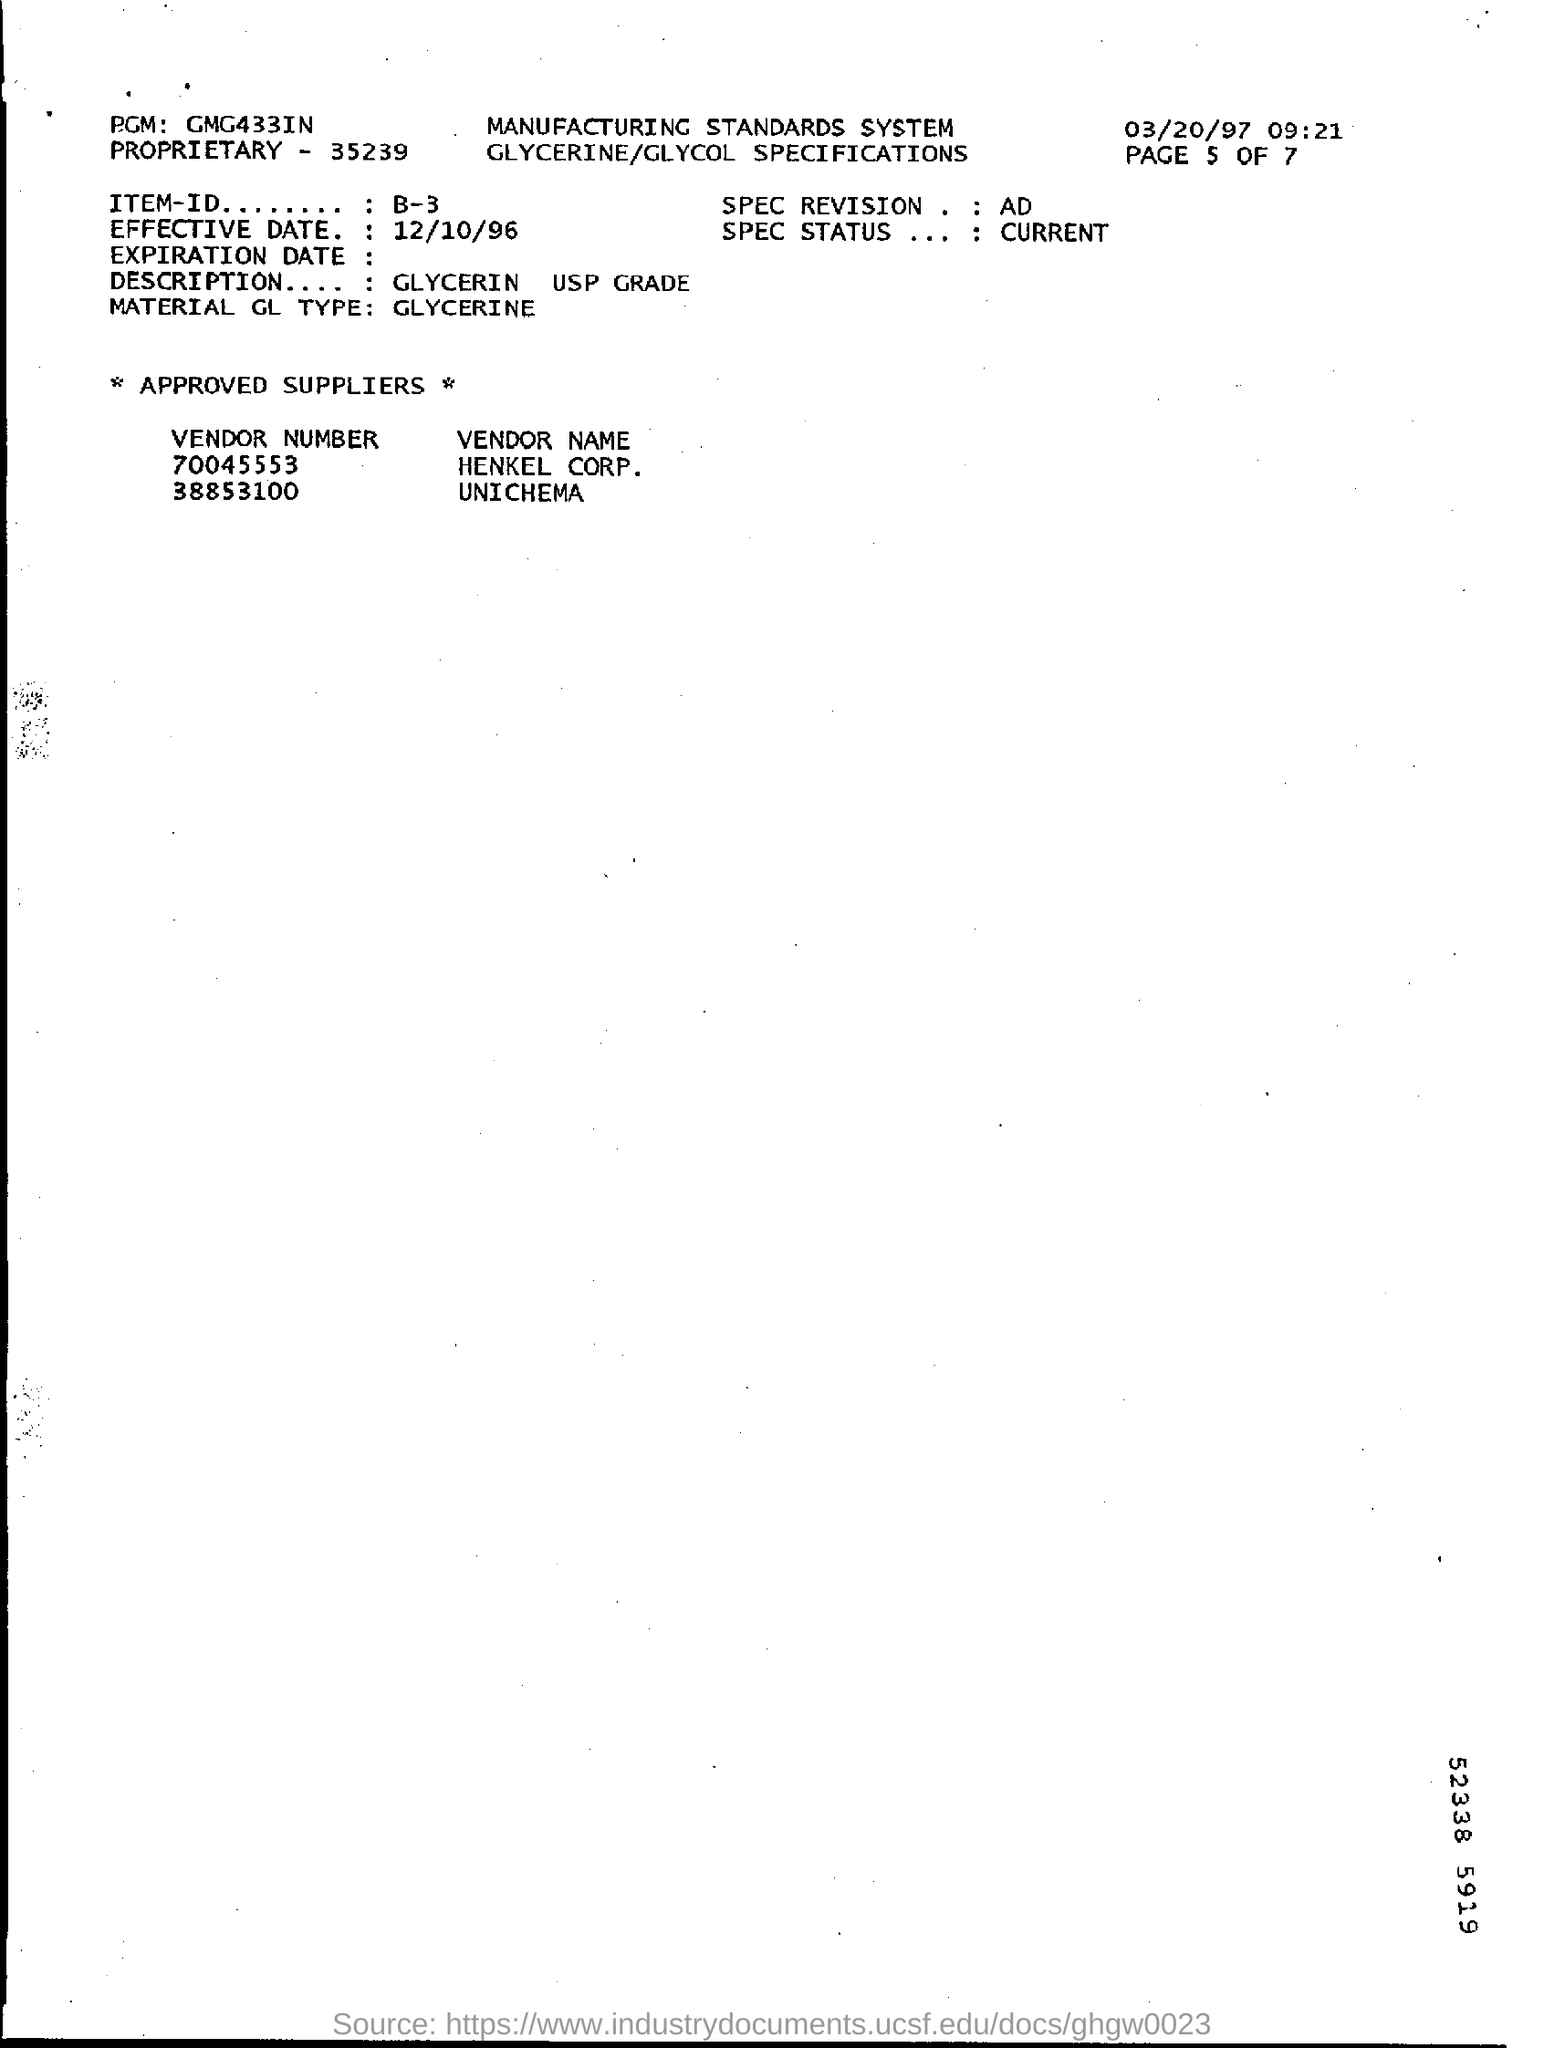What is Item-ID Number ?
Give a very brief answer. B-3. Which is the effective date ?
Offer a terse response. 12/10/96. What is material GL Type ?
Offer a terse response. GLYCERINE. 